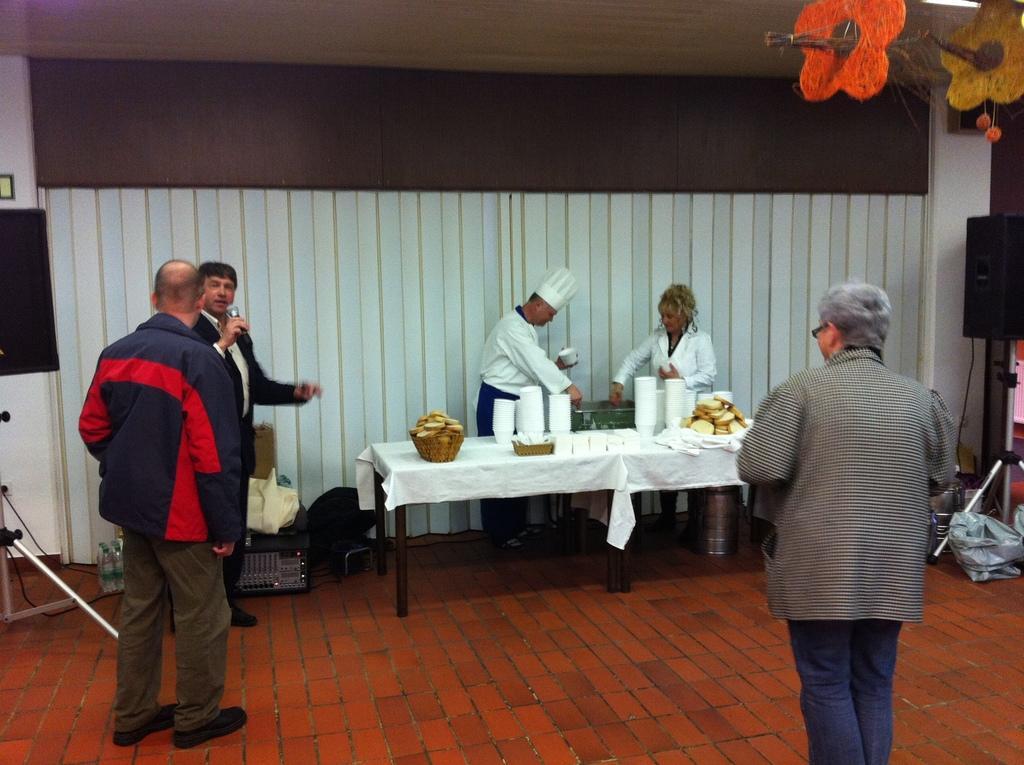How would you summarize this image in a sentence or two? In this image, There is a floor made of bricks in brown color, In the middle there is a table which is covered by a white color cloth on that table there are some white color bowls and there are some glasses, There are some people standing and there is a man standing and holding a microphone, In the background there is a white color wall. 